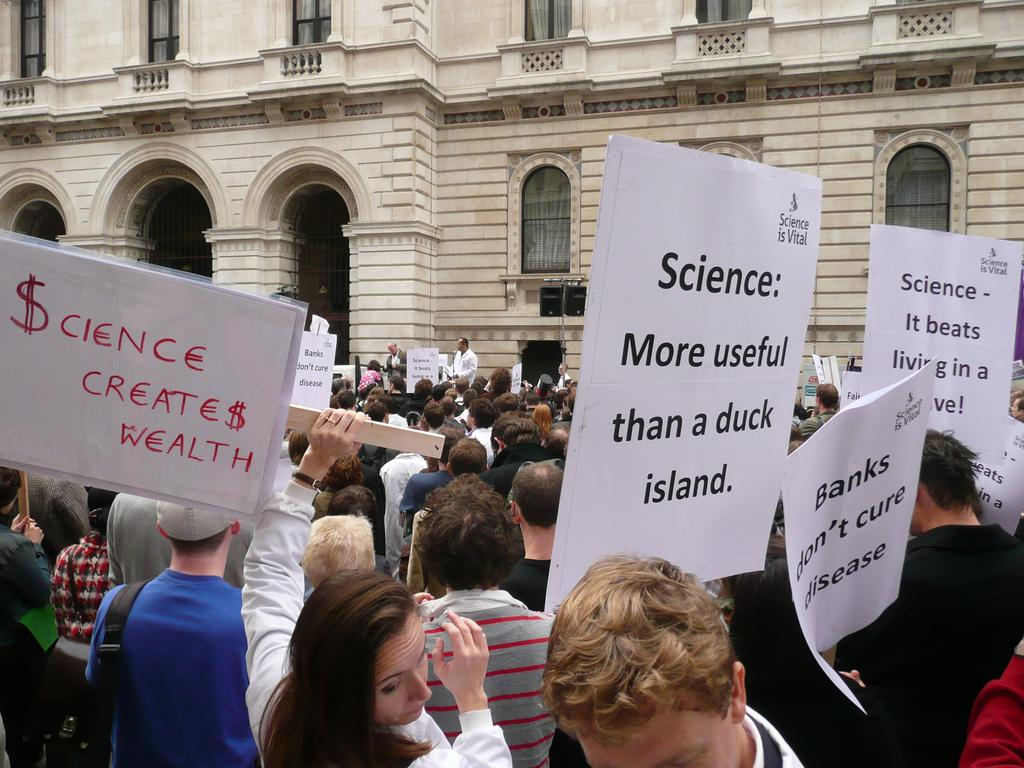How many people are present in the image? There are many people in the image. What are some of the people holding in the image? Some people are holding placards in the image. What can be seen in the background of the image? There is a building with windows in the background. What architectural feature is present on the building? The building has arches. What type of plastic is being used to tie the knot in the image? There is no plastic or knot present in the image. 